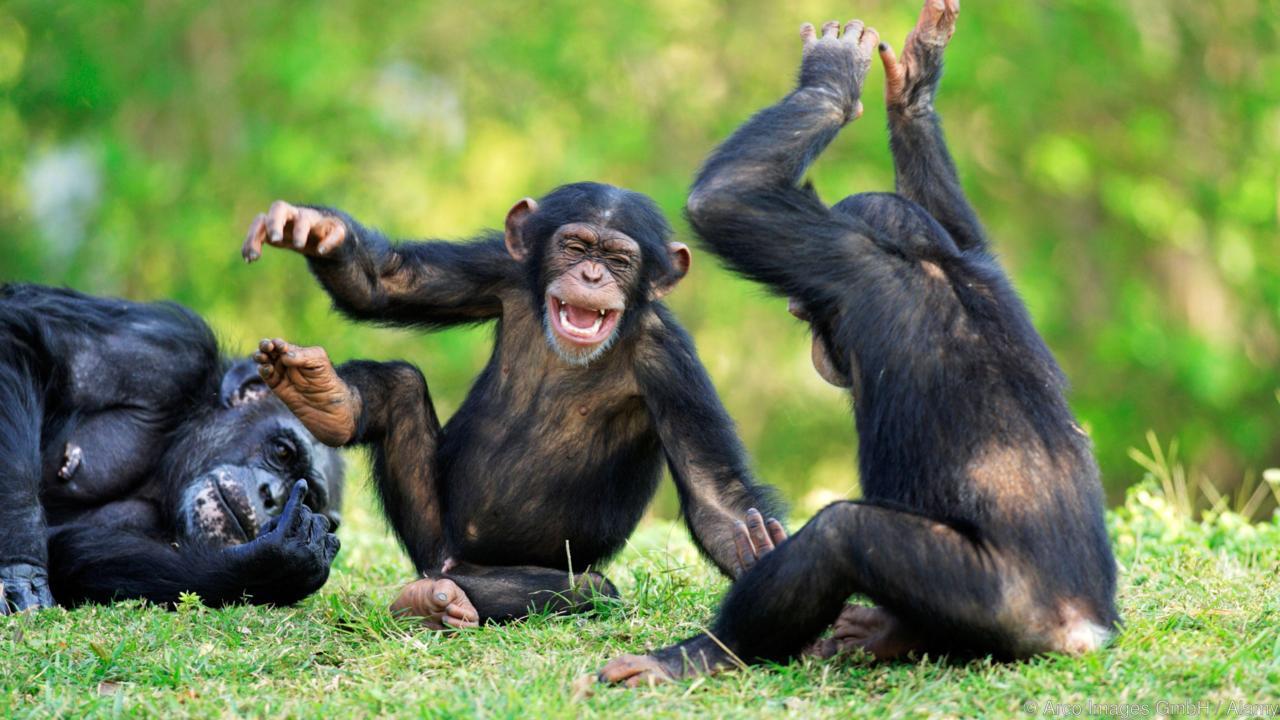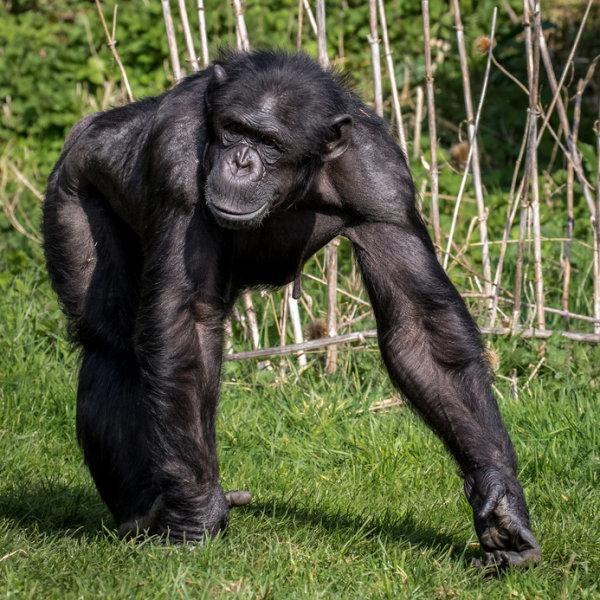The first image is the image on the left, the second image is the image on the right. For the images displayed, is the sentence "An image includes a camera-facing chimp with a wide-open mouth showing at least one row of teeth." factually correct? Answer yes or no. Yes. 